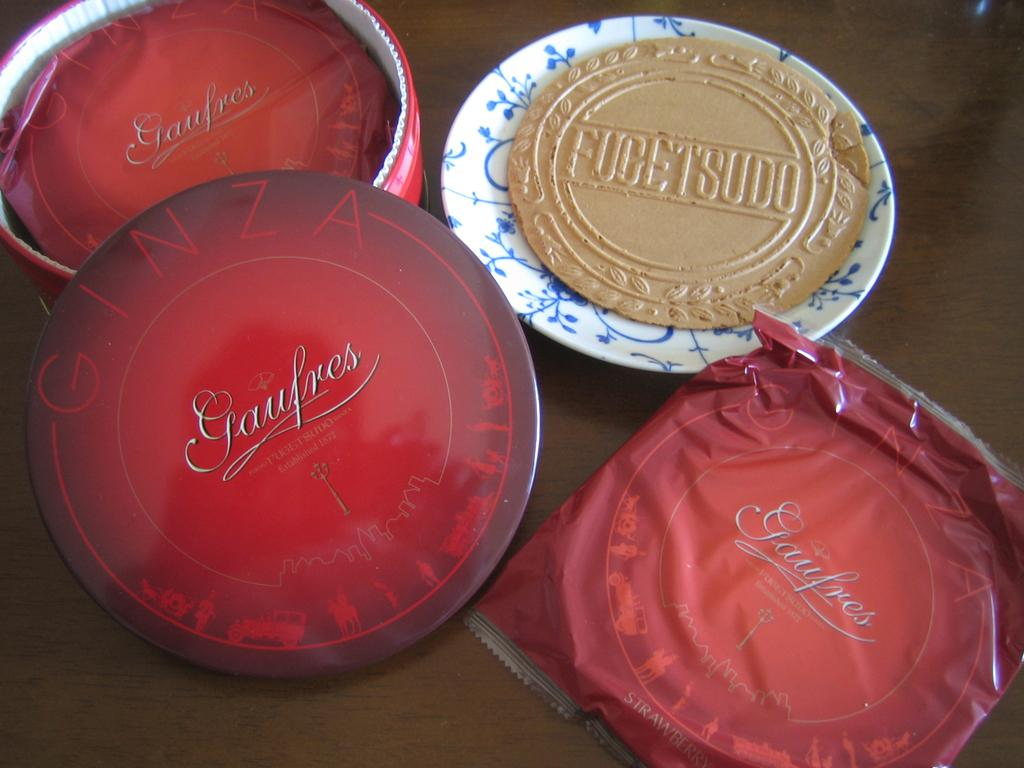What object can be seen in the picture that is typically used for serving food? There is a plate in the picture. What is the color of the cover visible in the image? The cover has a red color. What can be found on the left side of the picture? There appears to be a bowl on the left side of the picture. What type of accessory is present in the image? There is a cap in the picture. How many goats are visible in the picture? There are no goats present in the image. What type of tree can be seen in the background of the picture? There is no tree visible in the image. 